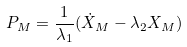Convert formula to latex. <formula><loc_0><loc_0><loc_500><loc_500>P _ { M } = \frac { 1 } { \lambda _ { 1 } } ( \dot { X } _ { M } - \lambda _ { 2 } X _ { M } )</formula> 